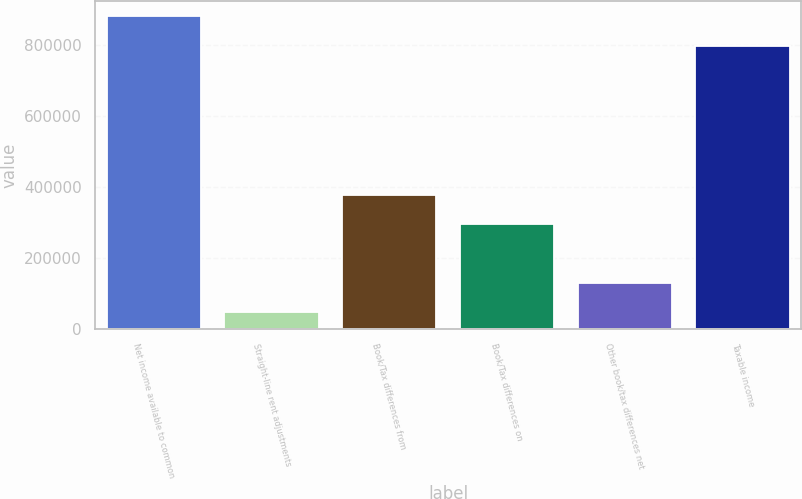<chart> <loc_0><loc_0><loc_500><loc_500><bar_chart><fcel>Net income available to common<fcel>Straight-line rent adjustments<fcel>Book/Tax differences from<fcel>Book/Tax differences on<fcel>Other book/tax differences net<fcel>Taxable income<nl><fcel>879607<fcel>48563<fcel>378592<fcel>296085<fcel>131070<fcel>797100<nl></chart> 